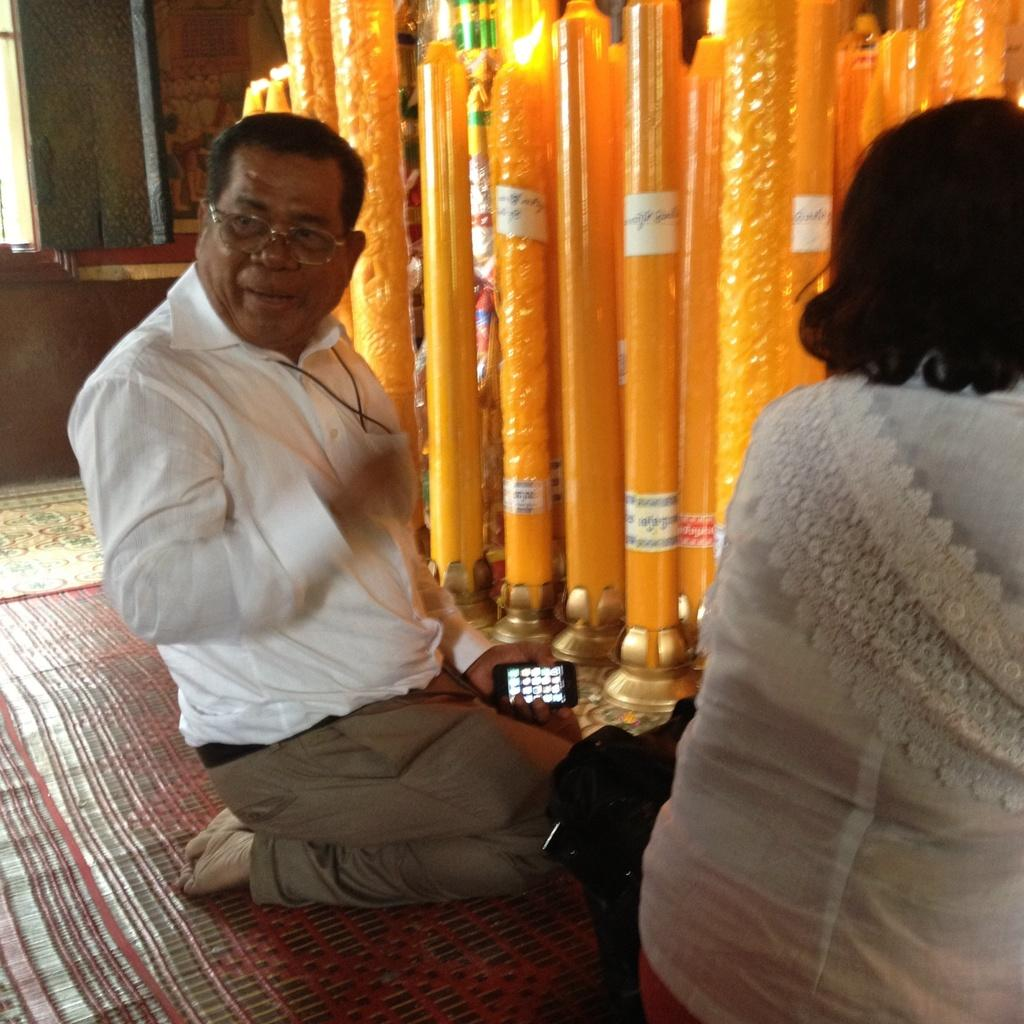What is the person in the image doing? The person is sitting on their knees in the image. What object is the person holding? The person is holding a cellphone. Who is beside the person in the image? There is a woman beside the person in the image. What can be seen in the background of the image? There are candles with flames on them in the background of the image. What type of feather can be seen on the bed in the image? There is no bed or feather present in the image. What tasks is the maid performing in the image? There is no maid present in the image. 